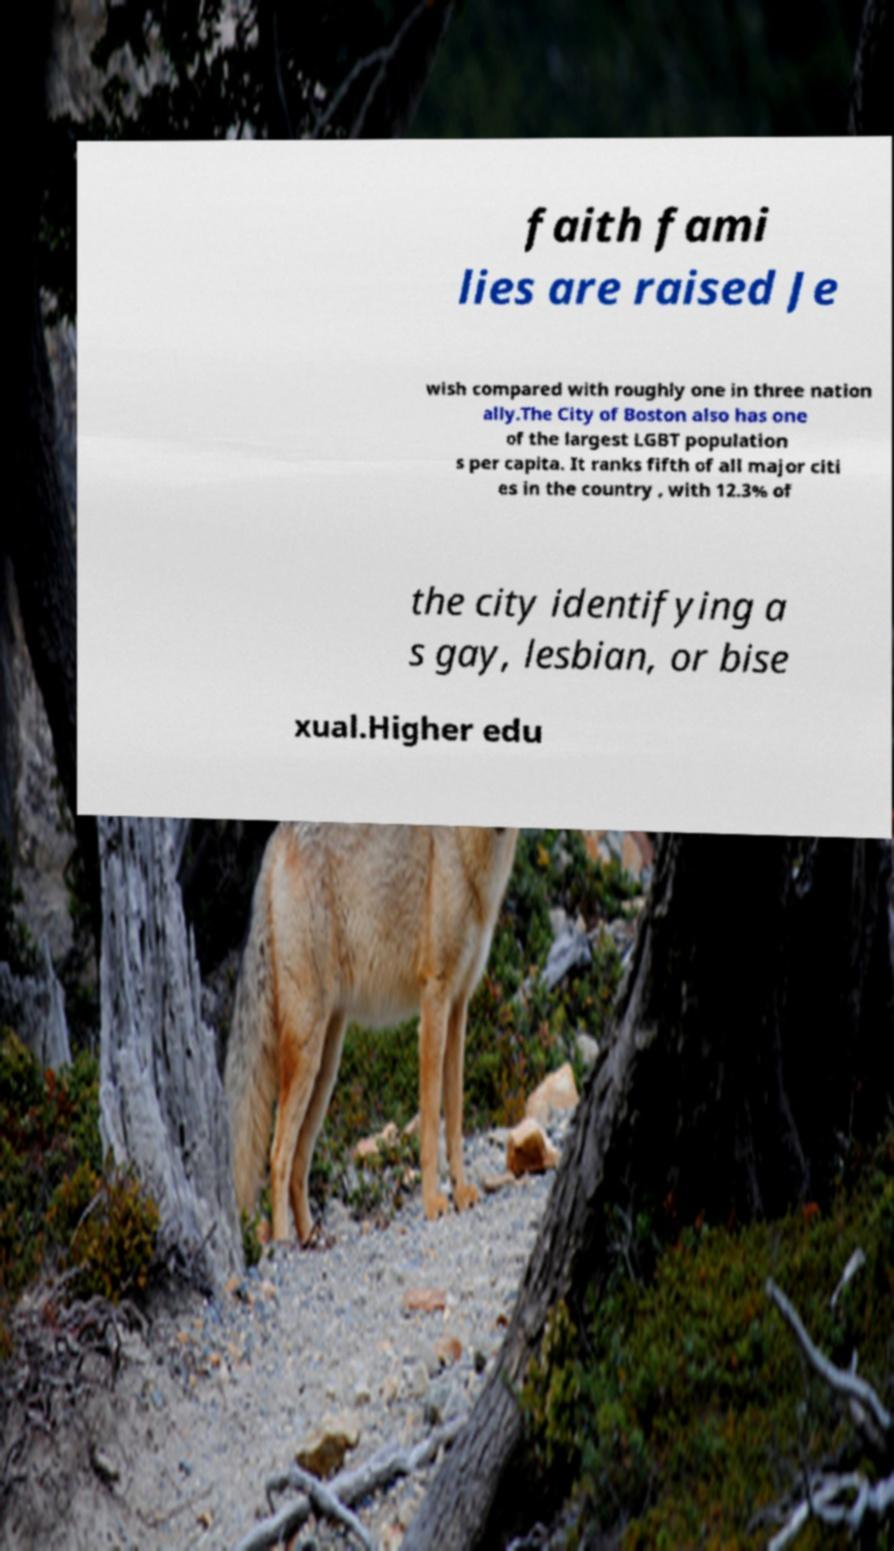Please read and relay the text visible in this image. What does it say? faith fami lies are raised Je wish compared with roughly one in three nation ally.The City of Boston also has one of the largest LGBT population s per capita. It ranks fifth of all major citi es in the country , with 12.3% of the city identifying a s gay, lesbian, or bise xual.Higher edu 